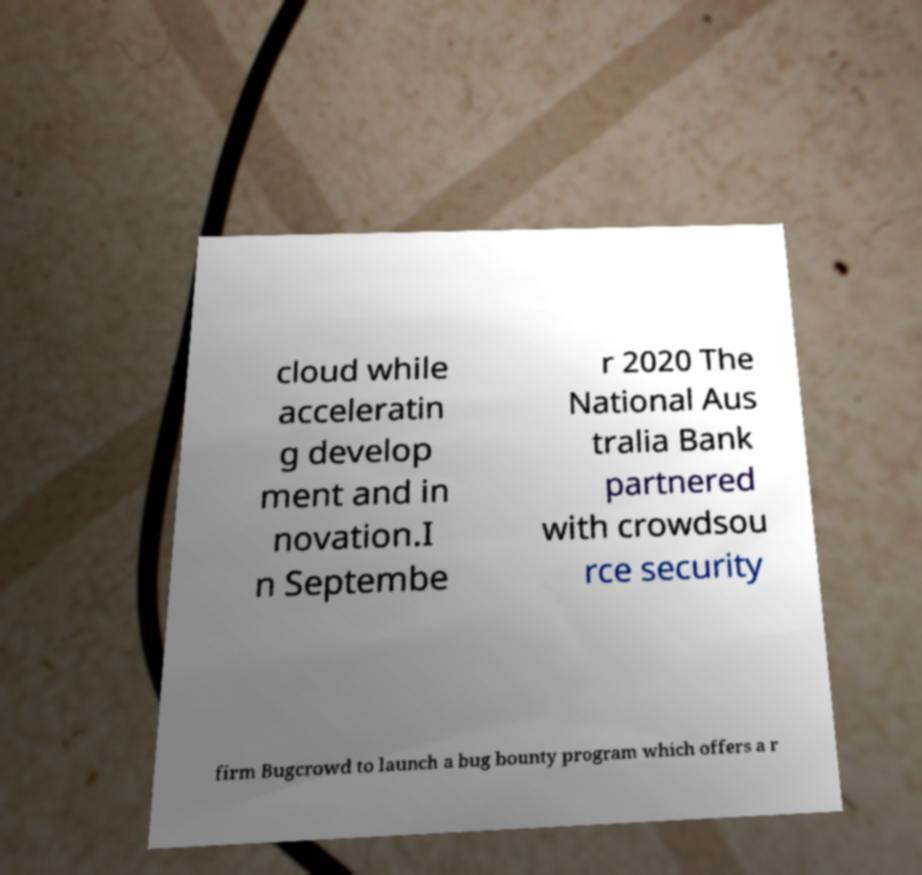Could you extract and type out the text from this image? cloud while acceleratin g develop ment and in novation.I n Septembe r 2020 The National Aus tralia Bank partnered with crowdsou rce security firm Bugcrowd to launch a bug bounty program which offers a r 